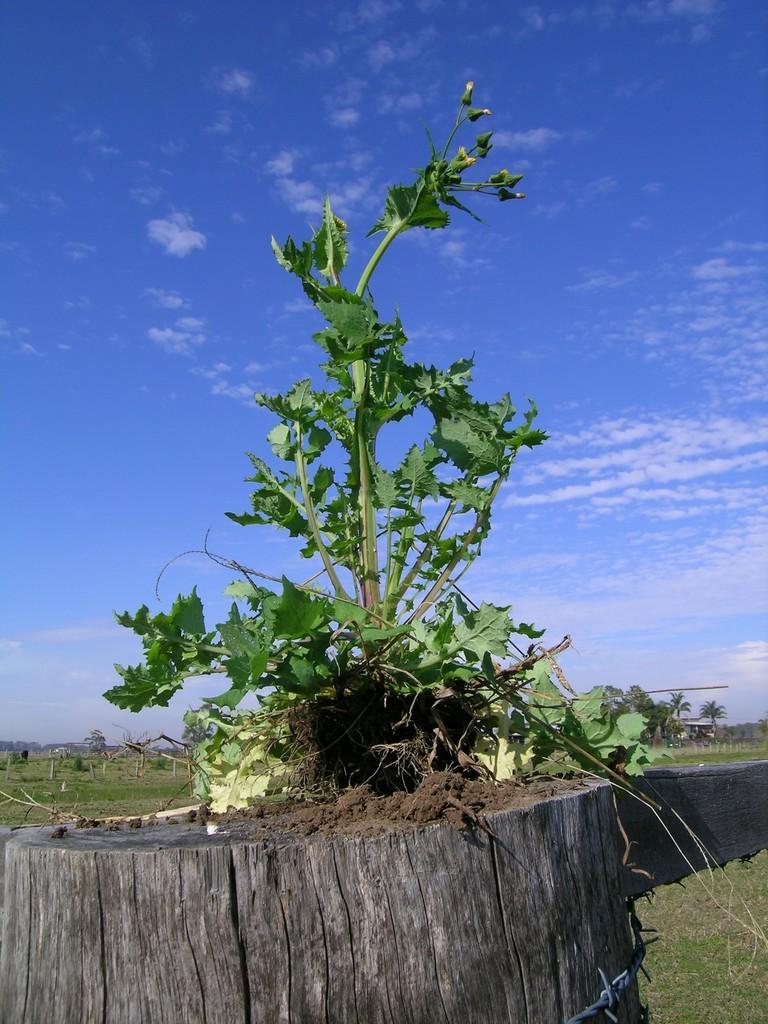Please provide a concise description of this image. In this image we can see grass, log, plant, and trees. In the background there is sky with clouds. 